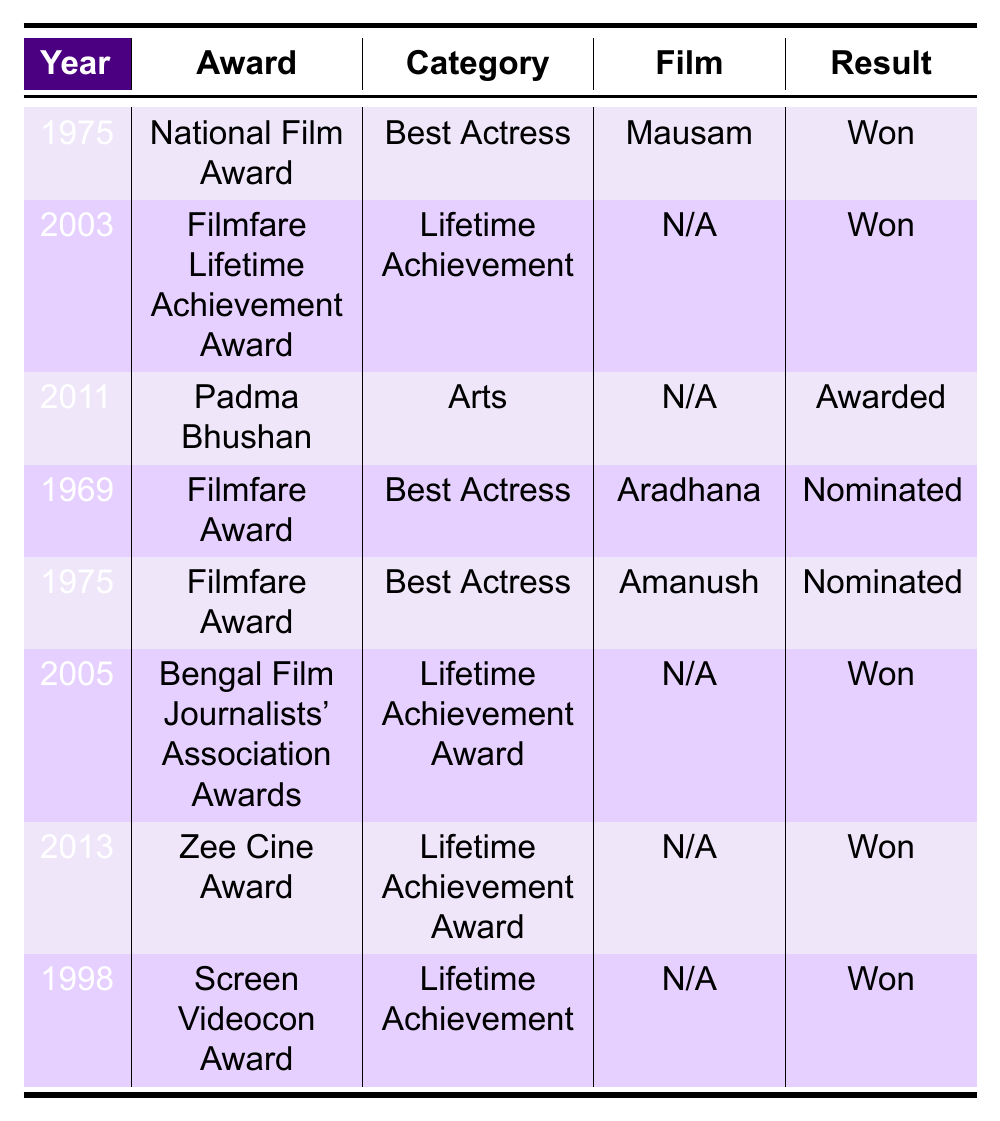What award did Sharmila Tagore win in 1975? The table indicates that in 1975, Sharmila Tagore won the National Film Award for Best Actress for her film "Mausam."
Answer: National Film Award How many Lifetime Achievement Awards has Sharmila Tagore received? Sharmila Tagore received three Lifetime Achievement Awards: the Filmfare Lifetime Achievement Award in 2003, the Bengal Film Journalists' Association Awards in 2005, and the Zee Cine Award in 2013.
Answer: Three Was Sharmila Tagore nominated for the Filmfare Award in 1975? Yes, the table shows that she was nominated for the Filmfare Award for Best Actress for the film "Amanush" in 1975.
Answer: Yes What is the latest award Sharmila Tagore received according to the table? The latest award listed is the Zee Cine Award for Lifetime Achievement Award in 2013.
Answer: Zee Cine Award In which year did Sharmila Tagore receive the Padma Bhushan? According to the table, Sharmila Tagore received the Padma Bhushan in 2011.
Answer: 2011 How many awards did Sharmila Tagore win compared to those she was nominated for? She won four awards (National Film Award, Filmfare Lifetime Achievement Award, Bengal Film Journalists' Association Awards, and Zee Cine Award) and was nominated twice (Filmfare Award for "Aradhana" and "Amanush"), thus winning more awards than nominations.
Answer: Won more Is it true that Sharmila Tagore has only been awarded Lifetime Achievement Awards since the 2000s? No, the table shows that she received a Lifetime Achievement Award in 2005 and again in 2013, but the National Film Award was won in 1975, indicating she was awarded before the 2000s as well.
Answer: False What percentage of the total awards and nominations listed were wins? There are eight entries in total (4 wins and 2 nominations), so the percentage of wins is (4/8)*100 = 50%.
Answer: 50% How many awards were given to Sharmila Tagore in the 2000s? In the 2000s, she received three awards: the Filmfare Lifetime Achievement Award in 2003, the Bengal Film Journalists' Association Awards in 2005, and the Zee Cine Award in 2013.
Answer: Three 